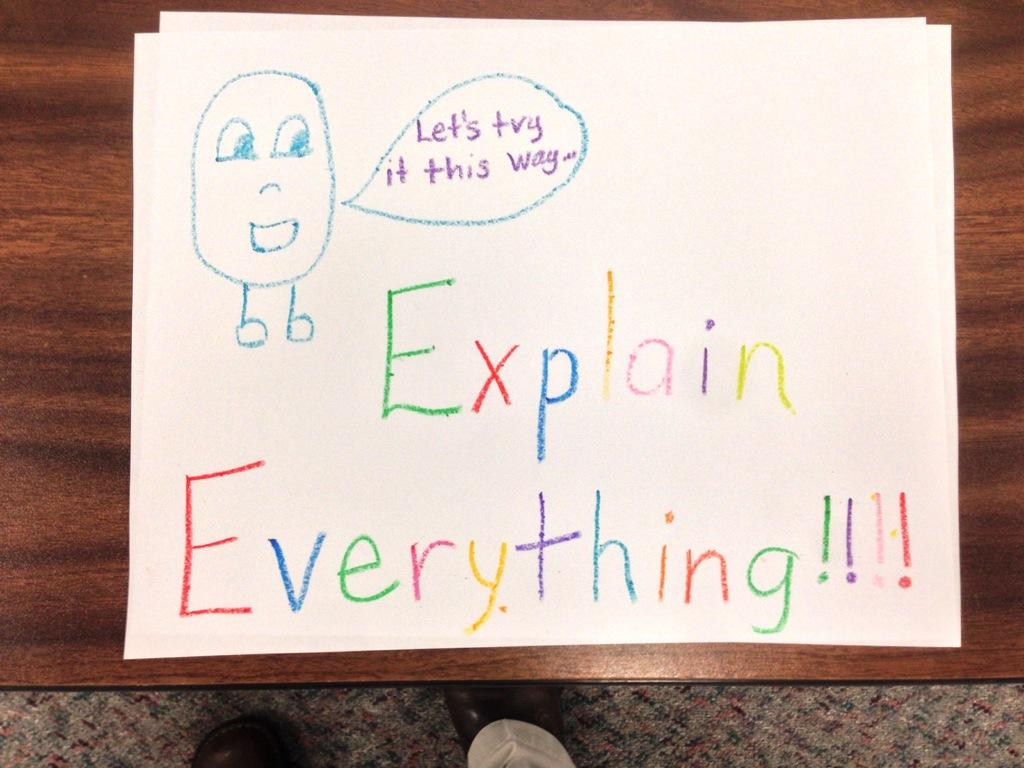<image>
Share a concise interpretation of the image provided. A drawing of a crude figure is saying, "Let's try it this way." 